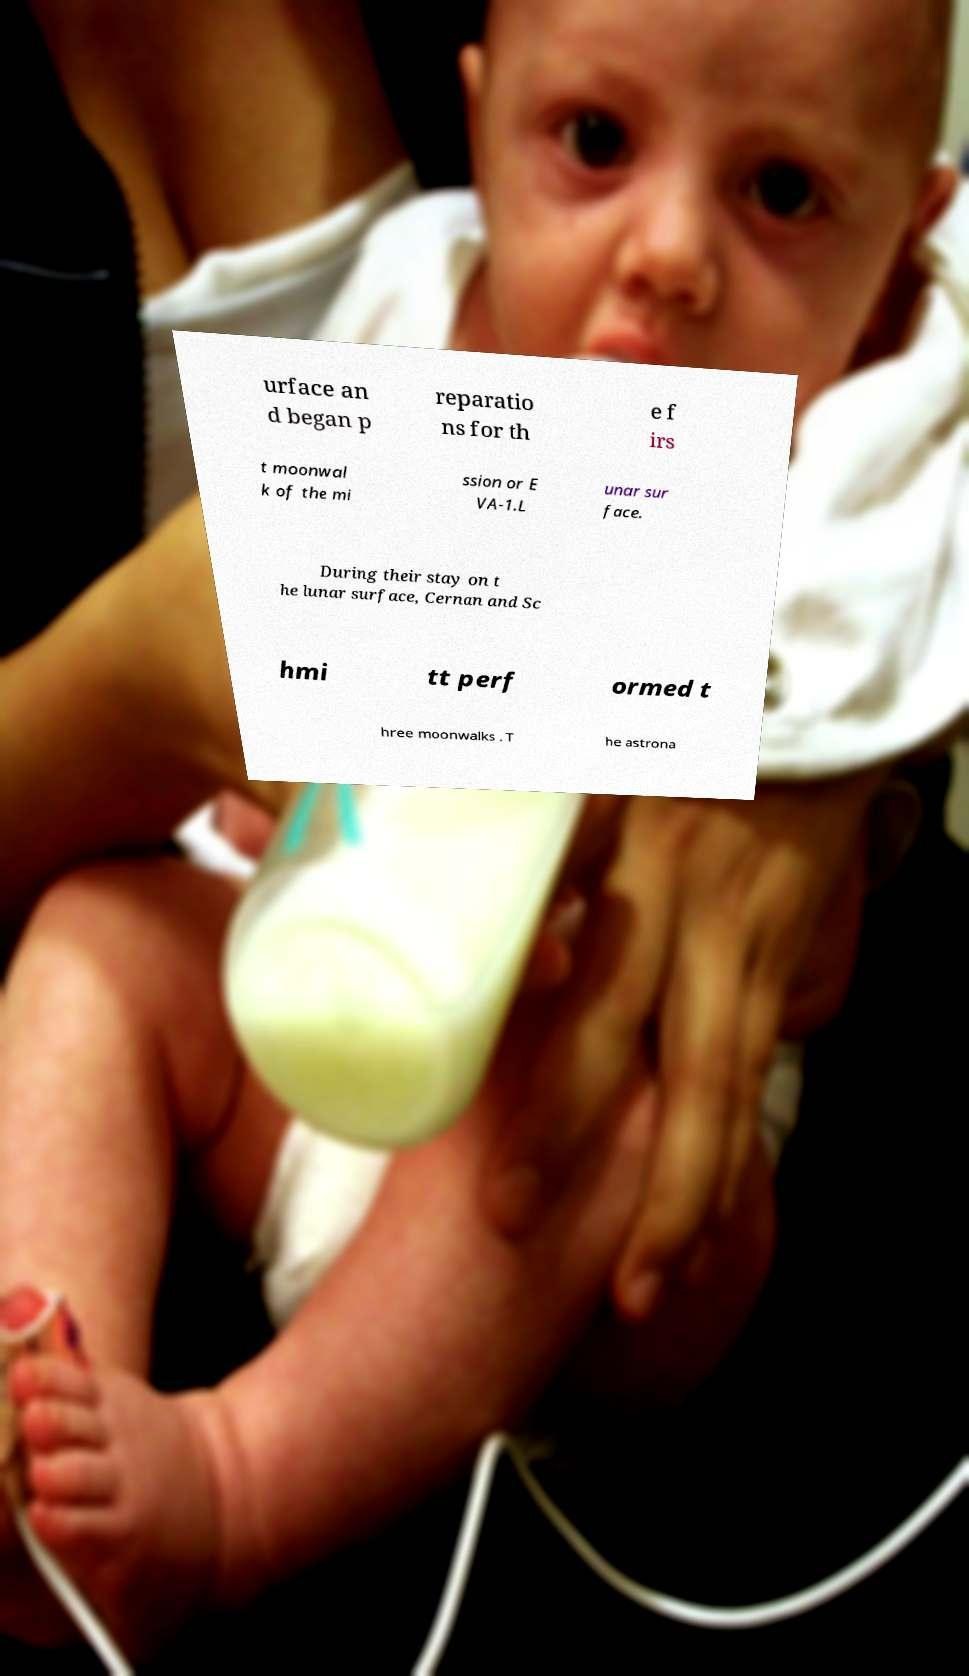For documentation purposes, I need the text within this image transcribed. Could you provide that? urface an d began p reparatio ns for th e f irs t moonwal k of the mi ssion or E VA-1.L unar sur face. During their stay on t he lunar surface, Cernan and Sc hmi tt perf ormed t hree moonwalks . T he astrona 